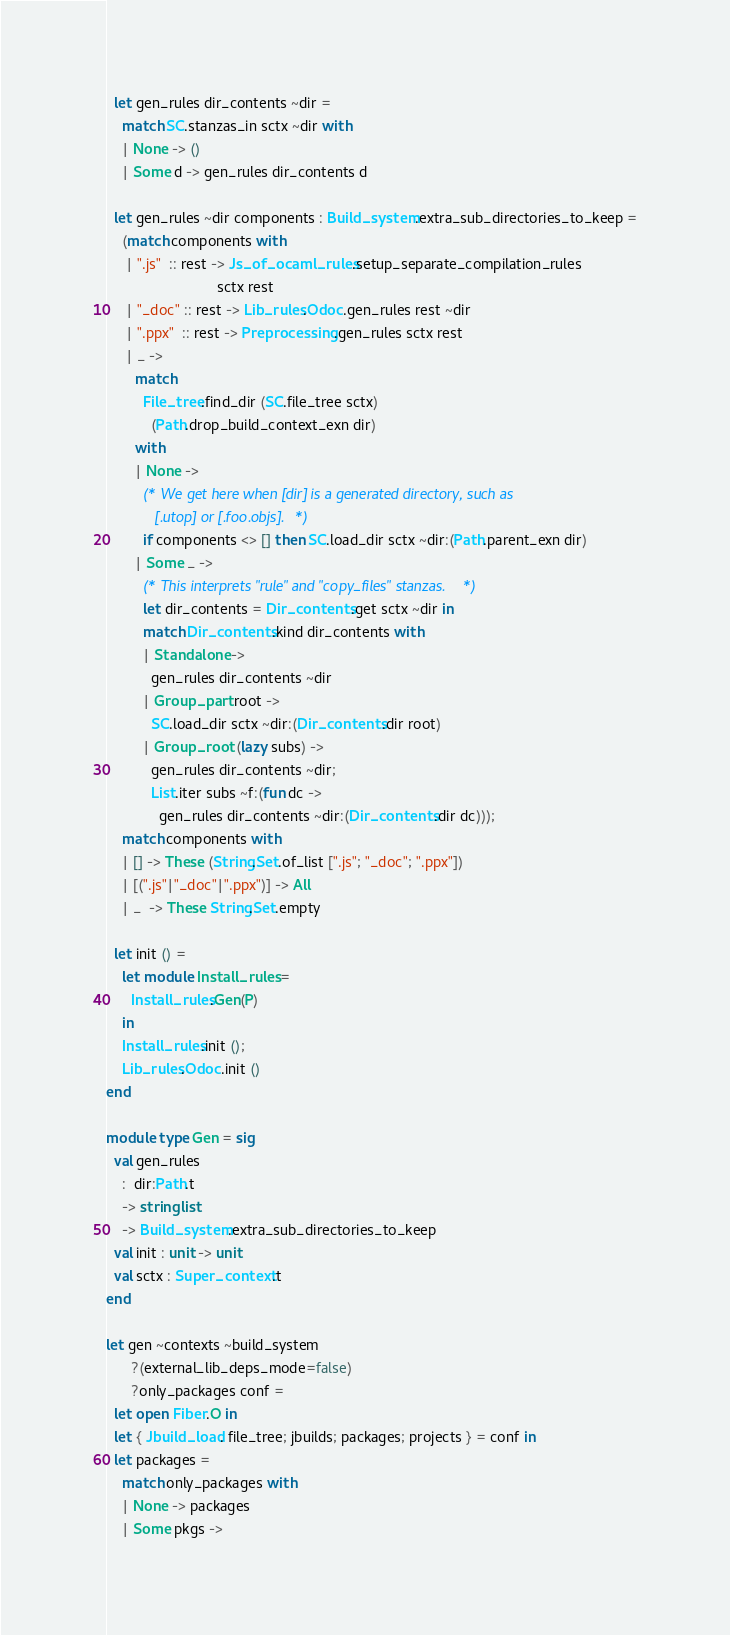Convert code to text. <code><loc_0><loc_0><loc_500><loc_500><_OCaml_>
  let gen_rules dir_contents ~dir =
    match SC.stanzas_in sctx ~dir with
    | None -> ()
    | Some d -> gen_rules dir_contents d

  let gen_rules ~dir components : Build_system.extra_sub_directories_to_keep =
    (match components with
     | ".js"  :: rest -> Js_of_ocaml_rules.setup_separate_compilation_rules
                           sctx rest
     | "_doc" :: rest -> Lib_rules.Odoc.gen_rules rest ~dir
     | ".ppx"  :: rest -> Preprocessing.gen_rules sctx rest
     | _ ->
       match
         File_tree.find_dir (SC.file_tree sctx)
           (Path.drop_build_context_exn dir)
       with
       | None ->
         (* We get here when [dir] is a generated directory, such as
            [.utop] or [.foo.objs]. *)
         if components <> [] then SC.load_dir sctx ~dir:(Path.parent_exn dir)
       | Some _ ->
         (* This interprets "rule" and "copy_files" stanzas. *)
         let dir_contents = Dir_contents.get sctx ~dir in
         match Dir_contents.kind dir_contents with
         | Standalone ->
           gen_rules dir_contents ~dir
         | Group_part root ->
           SC.load_dir sctx ~dir:(Dir_contents.dir root)
         | Group_root (lazy subs) ->
           gen_rules dir_contents ~dir;
           List.iter subs ~f:(fun dc ->
             gen_rules dir_contents ~dir:(Dir_contents.dir dc)));
    match components with
    | [] -> These (String.Set.of_list [".js"; "_doc"; ".ppx"])
    | [(".js"|"_doc"|".ppx")] -> All
    | _  -> These String.Set.empty

  let init () =
    let module Install_rules =
      Install_rules.Gen(P)
    in
    Install_rules.init ();
    Lib_rules.Odoc.init ()
end

module type Gen = sig
  val gen_rules
    :  dir:Path.t
    -> string list
    -> Build_system.extra_sub_directories_to_keep
  val init : unit -> unit
  val sctx : Super_context.t
end

let gen ~contexts ~build_system
      ?(external_lib_deps_mode=false)
      ?only_packages conf =
  let open Fiber.O in
  let { Jbuild_load. file_tree; jbuilds; packages; projects } = conf in
  let packages =
    match only_packages with
    | None -> packages
    | Some pkgs -></code> 